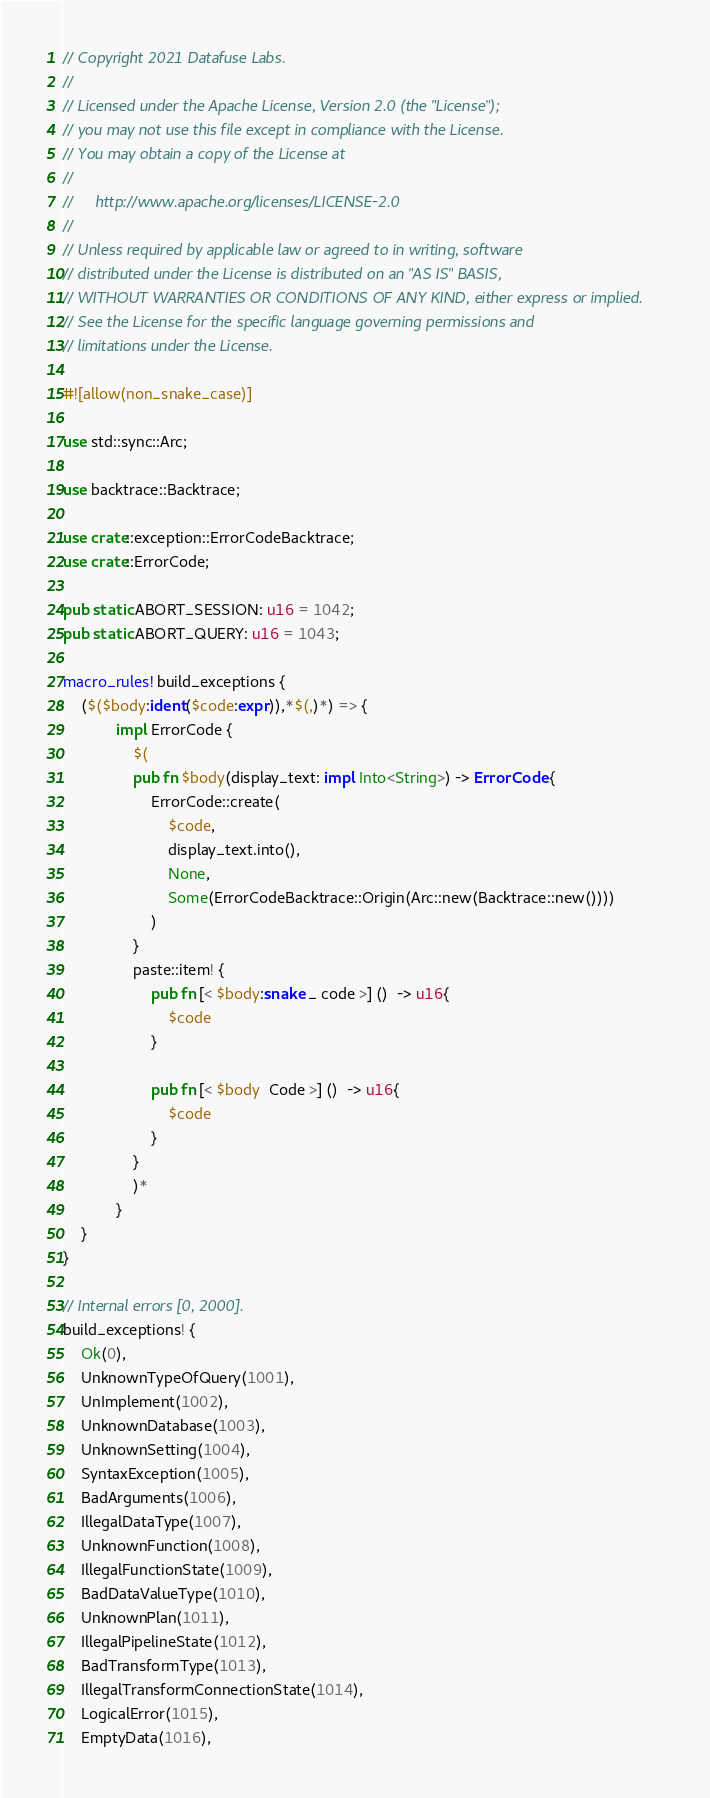Convert code to text. <code><loc_0><loc_0><loc_500><loc_500><_Rust_>// Copyright 2021 Datafuse Labs.
//
// Licensed under the Apache License, Version 2.0 (the "License");
// you may not use this file except in compliance with the License.
// You may obtain a copy of the License at
//
//     http://www.apache.org/licenses/LICENSE-2.0
//
// Unless required by applicable law or agreed to in writing, software
// distributed under the License is distributed on an "AS IS" BASIS,
// WITHOUT WARRANTIES OR CONDITIONS OF ANY KIND, either express or implied.
// See the License for the specific language governing permissions and
// limitations under the License.

#![allow(non_snake_case)]

use std::sync::Arc;

use backtrace::Backtrace;

use crate::exception::ErrorCodeBacktrace;
use crate::ErrorCode;

pub static ABORT_SESSION: u16 = 1042;
pub static ABORT_QUERY: u16 = 1043;

macro_rules! build_exceptions {
    ($($body:ident($code:expr)),*$(,)*) => {
            impl ErrorCode {
                $(
                pub fn $body(display_text: impl Into<String>) -> ErrorCode {
                    ErrorCode::create(
                        $code,
                        display_text.into(),
                        None,
                        Some(ErrorCodeBacktrace::Origin(Arc::new(Backtrace::new())))
                    )
                }
                paste::item! {
                    pub fn [< $body:snake _ code >] ()  -> u16{
                        $code
                    }

                    pub fn [< $body  Code >] ()  -> u16{
                        $code
                    }
                }
                )*
            }
    }
}

// Internal errors [0, 2000].
build_exceptions! {
    Ok(0),
    UnknownTypeOfQuery(1001),
    UnImplement(1002),
    UnknownDatabase(1003),
    UnknownSetting(1004),
    SyntaxException(1005),
    BadArguments(1006),
    IllegalDataType(1007),
    UnknownFunction(1008),
    IllegalFunctionState(1009),
    BadDataValueType(1010),
    UnknownPlan(1011),
    IllegalPipelineState(1012),
    BadTransformType(1013),
    IllegalTransformConnectionState(1014),
    LogicalError(1015),
    EmptyData(1016),</code> 